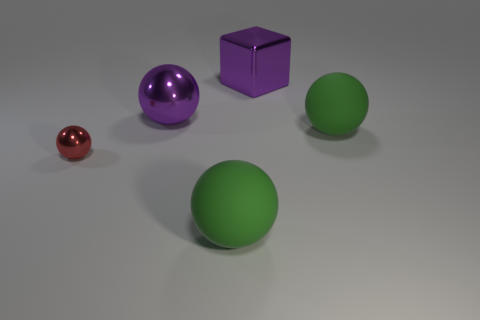Subtract all big metallic spheres. How many spheres are left? 3 Subtract all red balls. How many balls are left? 3 Add 3 cubes. How many objects exist? 8 Subtract all gray cubes. How many green balls are left? 2 Subtract all balls. How many objects are left? 1 Add 3 big shiny spheres. How many big shiny spheres exist? 4 Subtract 0 brown cylinders. How many objects are left? 5 Subtract all purple balls. Subtract all brown cylinders. How many balls are left? 3 Subtract all small yellow rubber spheres. Subtract all red metallic objects. How many objects are left? 4 Add 2 big green rubber objects. How many big green rubber objects are left? 4 